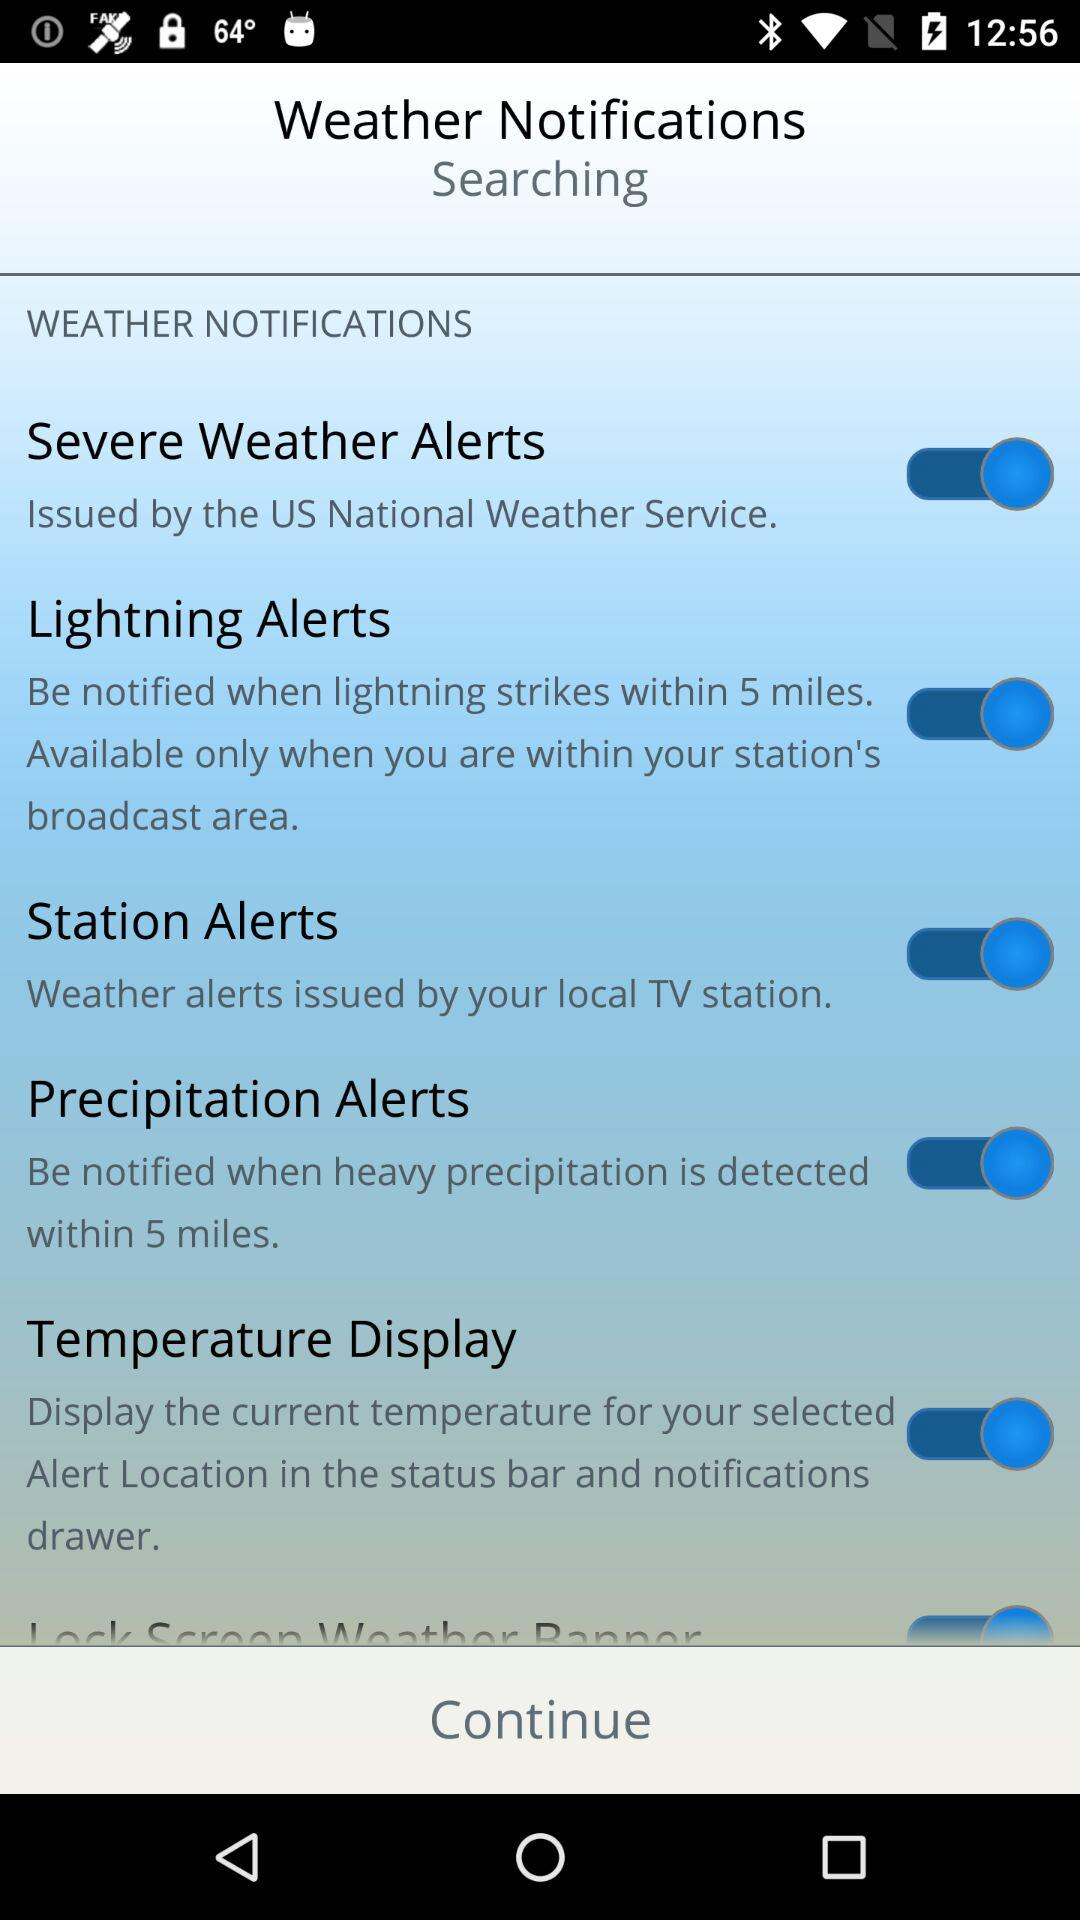Severe weather alerts are issued by whom? It is issued by US National Weather Service. 